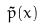Convert formula to latex. <formula><loc_0><loc_0><loc_500><loc_500>\tilde { p } ( x )</formula> 